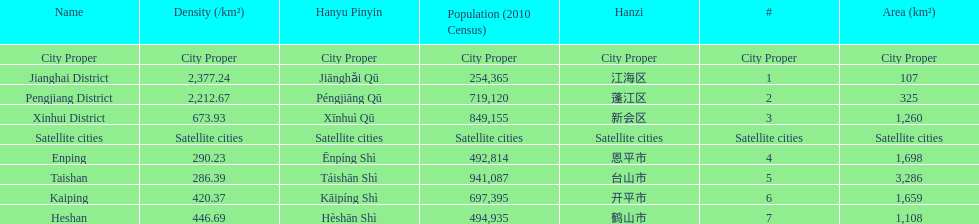What is the most populated district? Taishan. 